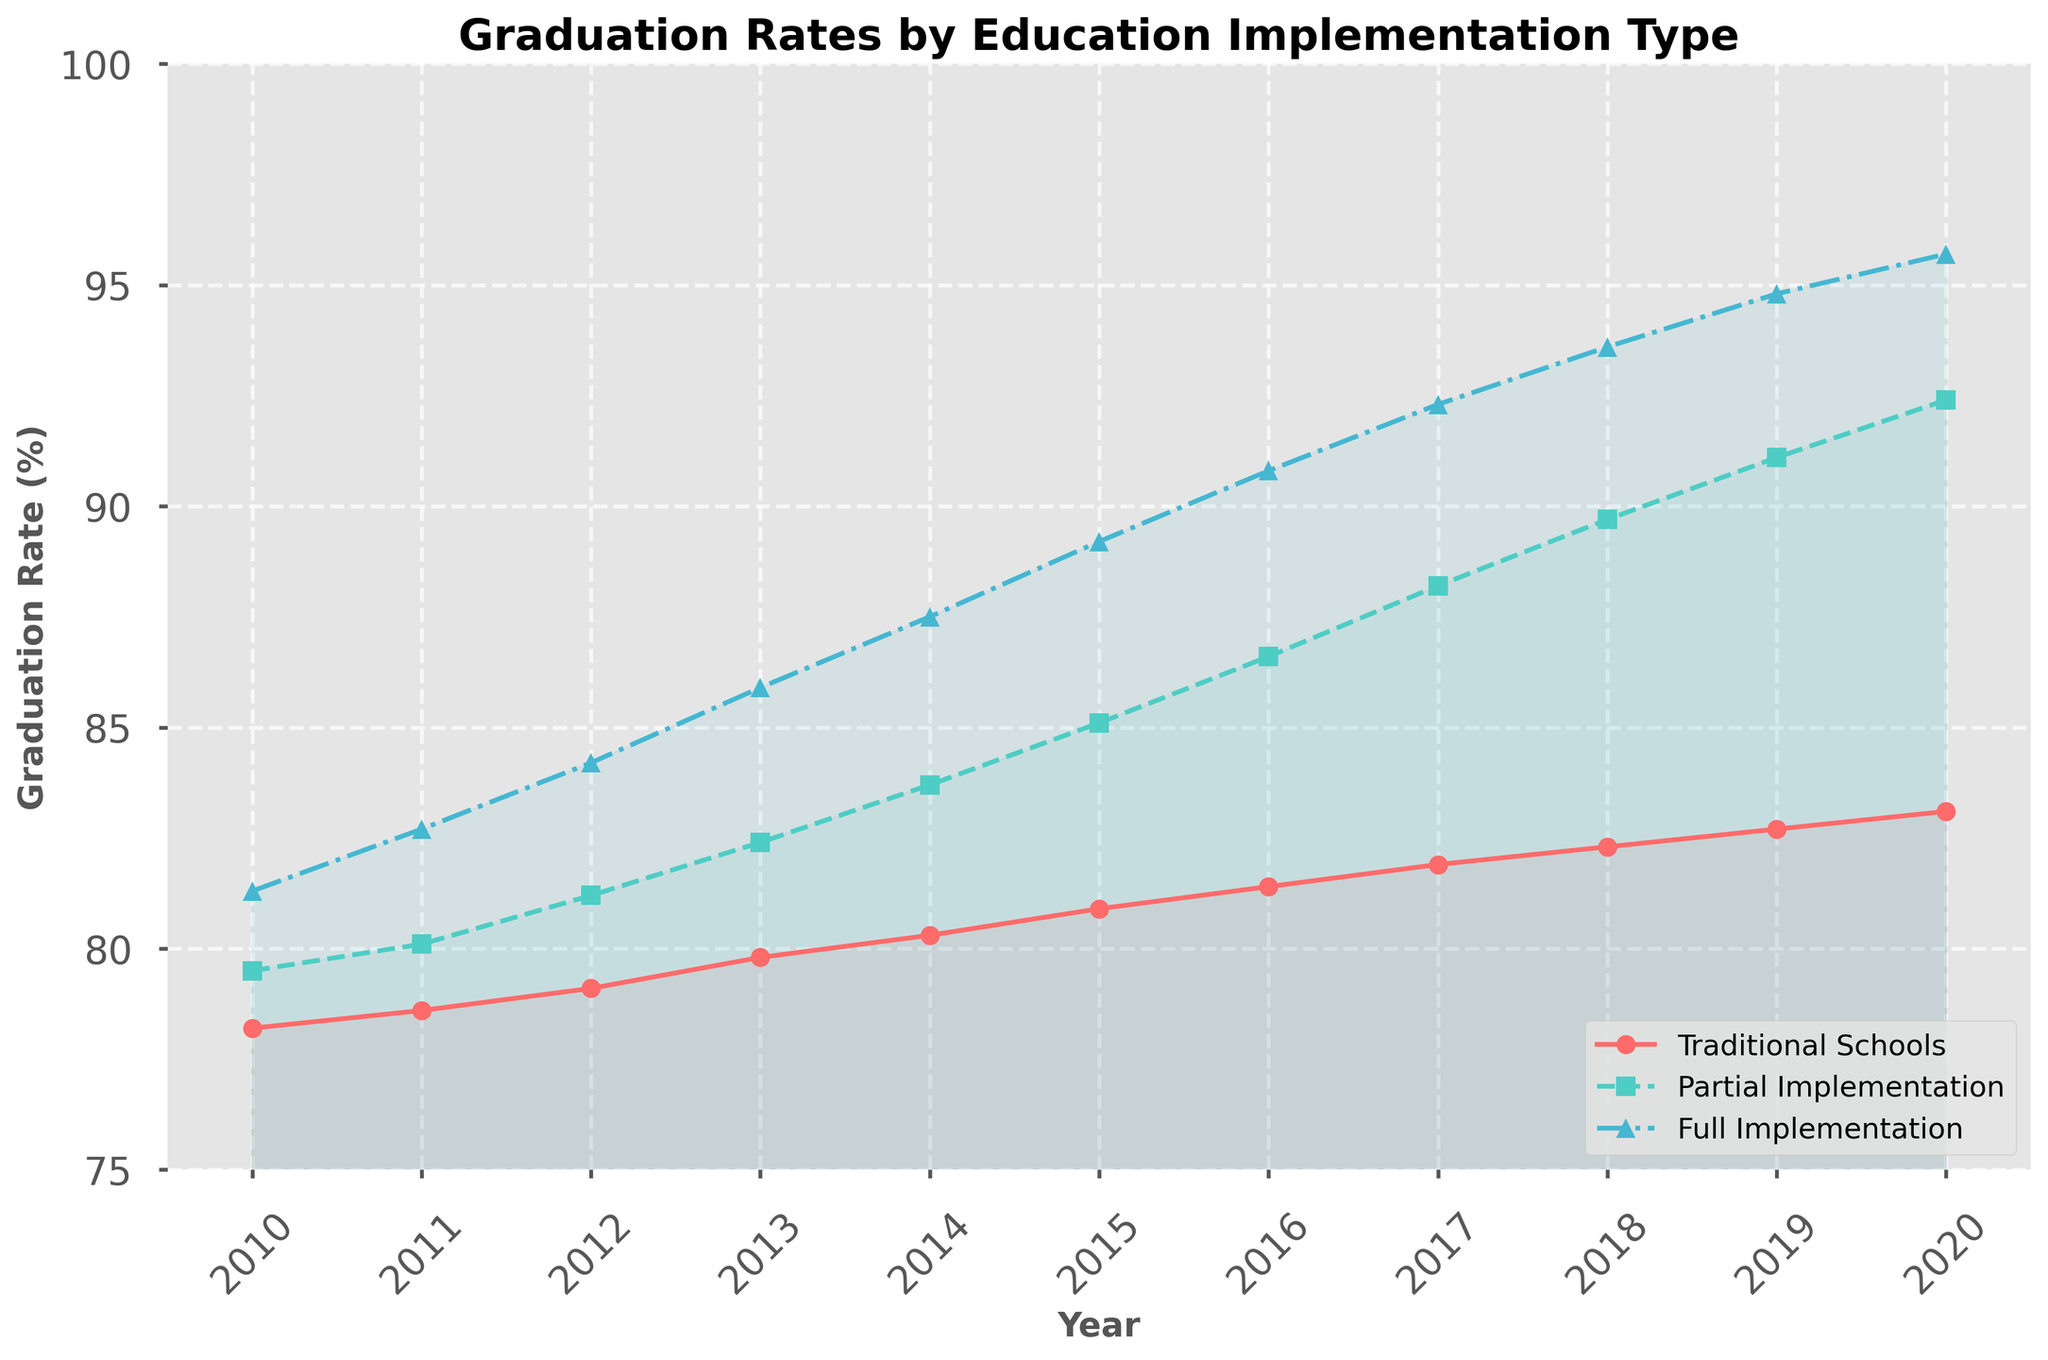What is the graduation rate difference between Traditional Schools and Full Implementation in 2010? To find the difference, look at the graduation rates for Traditional Schools and Full Implementation in 2010. Subtract the Traditional Schools rate from the Full Implementation rate: 81.3 - 78.2 = 3.1.
Answer: 3.1 Which year shows the largest graduation rate increase for Traditional Schools from the previous year? Inspect the yearly rates for Traditional Schools and identify the year with the largest increase from the previous year. The increases are: 2011 (78.6-78.2=0.4), 2012 (79.1-78.6=0.5), 2013 (79.8-79.1=0.7), 2014 (80.3-79.8=0.5), 2015 (80.9-80.3=0.6), 2016 (81.4-80.9=0.5), 2017 (81.9-81.4=0.5), 2018 (82.3-81.9=0.4), 2019 (82.7-82.3=0.4), 2020 (83.1-82.7=0.4). The largest increase occurred between 2012 and 2013.
Answer: 2013 In 2020, how many percentage points higher is the graduation rate for Full Implementation schools compared to Traditional Schools? Compare the graduation rates for Full Implementation and Traditional Schools in 2020. Subtract the Traditional Schools rate from the Full Implementation rate: 95.7 - 83.1 = 12.6.
Answer: 12.6 During which year did schools with Partial Implementation surpass 85% graduation rate? Identify the year where the Partial Implementation graduation rate first exceeds 85%. It reached 85.1% in 2015.
Answer: 2015 How many years did it take for Traditional Schools to go from a graduation rate of 78.2% in 2010 to above 80%? Find the first year the Traditional Schools' graduation rate exceeded 80%. It happened in 2014 (80.3%). Compute the difference in years from 2010 to 2014: 2014 - 2010 = 4.
Answer: 4 By how many percentage points did the Full Implementation schools' graduation rate increase from 2010 to 2020? Subtract the Full Implementation graduation rate in 2010 from the rate in 2020: 95.7 - 81.3 = 14.4.
Answer: 14.4 Which category showed the highest graduation rate in 2012? Compare the rates across all categories for 2012: Traditional Schools (79.1), Partial Implementation (81.2), Full Implementation (84.2). The highest rate is for Full Implementation.
Answer: Full Implementation Do Traditional Schools ever achieve a graduation rate above 85% by 2020? Review the Traditional Schools graduation rates across the years to see if any year shows a rate above 85%. The highest rate is 83.1% in 2020, which is below 85%.
Answer: No How did graduation rates for Partial Implementation change between 2015 and 2016? Compare the graduation rates for 2015 (85.1) and 2016 (86.6). The rate increased by 1.5 percentage points: 86.6 - 85.1 = 1.5.
Answer: 1.5 In which year did the Full Implementation schools achieve their highest graduation rate increase from the previous year? Inspect the yearly rates for Full Implementation and identify the largest increase from the previous year: 2011 (82.7-81.3=1.4), 2012 (84.2-82.7=1.5), 2013 (85.9-84.2=1.7), 2014 (87.5-85.9=1.6), 2015 (89.2-87.5=1.7), 2016 (90.8-89.2=1.6), 2017 (92.3-90.8=1.5), 2018 (93.6-92.3=1.3), 2019 (94.8-93.6=1.2), 2020 (95.7-94.8=0.9). The largest increase occurred between 2012 and 2013 and between 2014 and 2015, both 1.7 percentage points.
Answer: 2013, 2015 